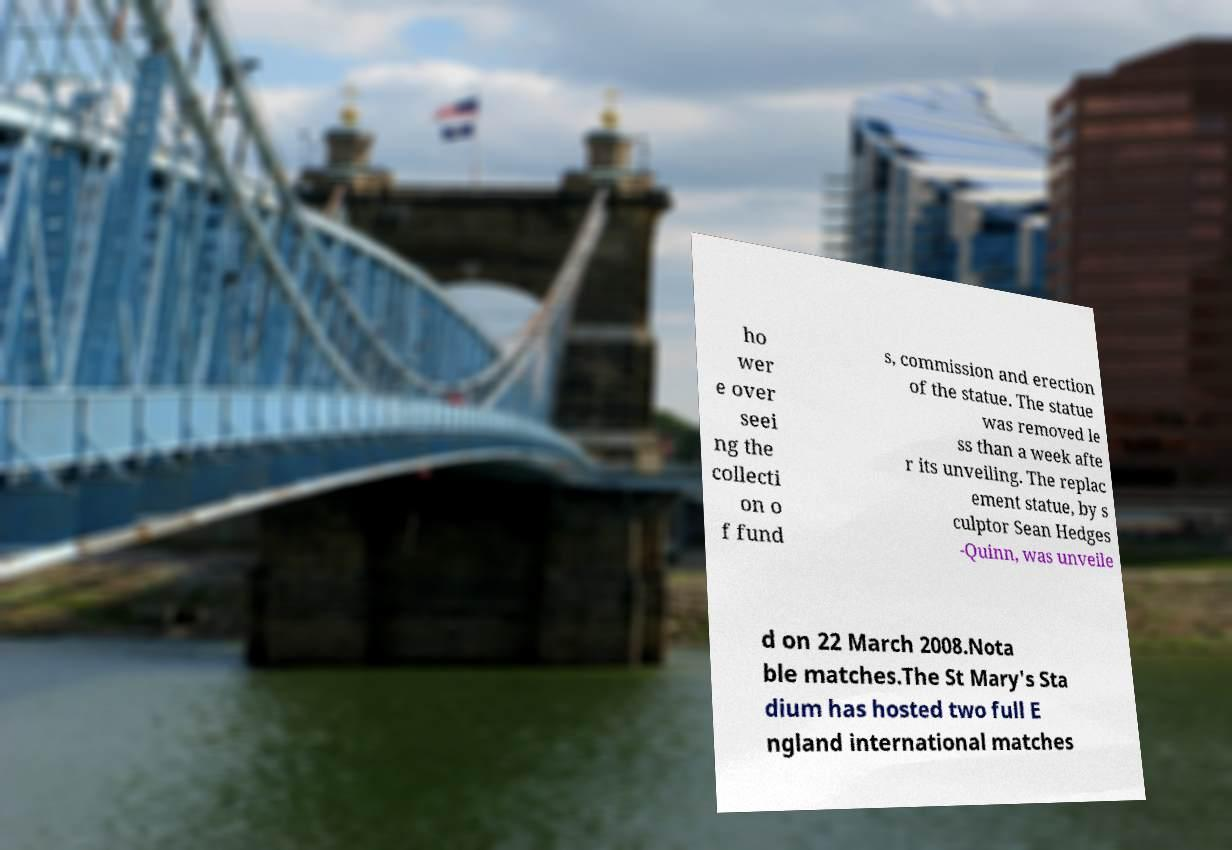For documentation purposes, I need the text within this image transcribed. Could you provide that? ho wer e over seei ng the collecti on o f fund s, commission and erection of the statue. The statue was removed le ss than a week afte r its unveiling. The replac ement statue, by s culptor Sean Hedges -Quinn, was unveile d on 22 March 2008.Nota ble matches.The St Mary's Sta dium has hosted two full E ngland international matches 